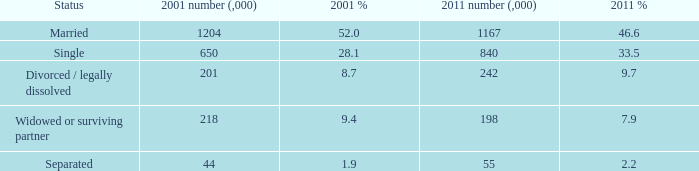What is the 2001 ratio for the status widowed or surviving partner? 9.4. 